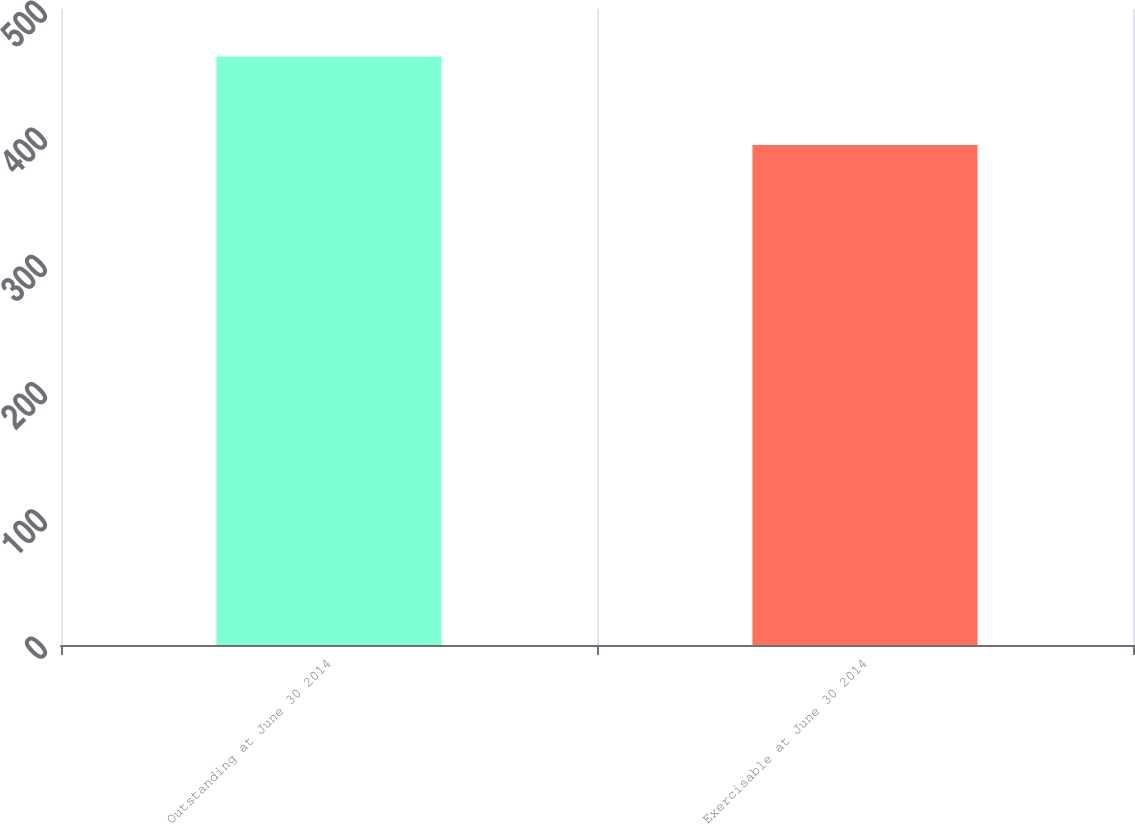<chart> <loc_0><loc_0><loc_500><loc_500><bar_chart><fcel>Outstanding at June 30 2014<fcel>Exercisable at June 30 2014<nl><fcel>462.7<fcel>393<nl></chart> 